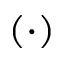Convert formula to latex. <formula><loc_0><loc_0><loc_500><loc_500>( \cdot )</formula> 